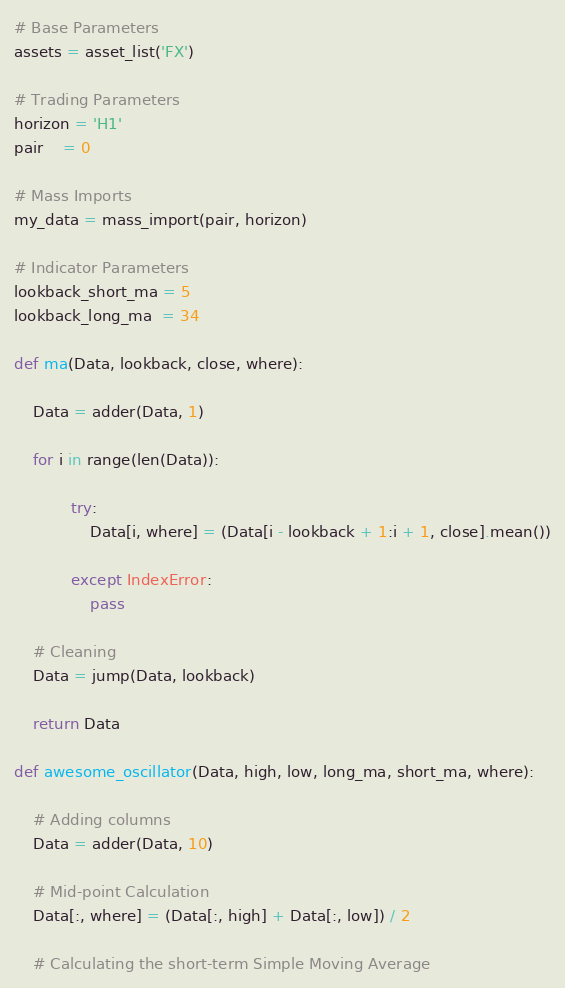<code> <loc_0><loc_0><loc_500><loc_500><_Python_># Base Parameters
assets = asset_list('FX') 

# Trading Parameters   
horizon = 'H1'
pair    = 0

# Mass Imports 
my_data = mass_import(pair, horizon)

# Indicator Parameters
lookback_short_ma = 5
lookback_long_ma  = 34

def ma(Data, lookback, close, where): 
    
    Data = adder(Data, 1)
    
    for i in range(len(Data)):
           
            try:
                Data[i, where] = (Data[i - lookback + 1:i + 1, close].mean())
            
            except IndexError:
                pass
            
    # Cleaning
    Data = jump(Data, lookback)
    
    return Data

def awesome_oscillator(Data, high, low, long_ma, short_ma, where):
    
    # Adding columns
    Data = adder(Data, 10)
    
    # Mid-point Calculation
    Data[:, where] = (Data[:, high] + Data[:, low]) / 2
    
    # Calculating the short-term Simple Moving Average</code> 